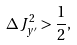Convert formula to latex. <formula><loc_0><loc_0><loc_500><loc_500>\Delta { J } _ { y ^ { \prime } } ^ { 2 } > \frac { 1 } { 2 } ,</formula> 